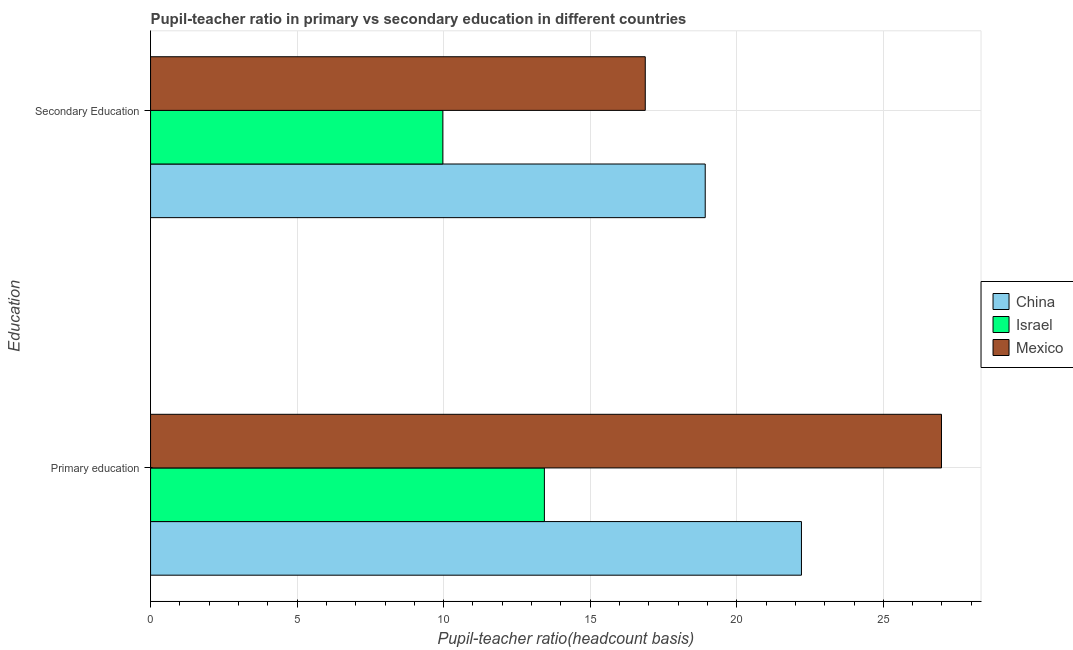How many different coloured bars are there?
Make the answer very short. 3. How many groups of bars are there?
Make the answer very short. 2. Are the number of bars per tick equal to the number of legend labels?
Offer a very short reply. Yes. Are the number of bars on each tick of the Y-axis equal?
Give a very brief answer. Yes. How many bars are there on the 1st tick from the top?
Your response must be concise. 3. What is the pupil teacher ratio on secondary education in China?
Your answer should be compact. 18.92. Across all countries, what is the maximum pupil-teacher ratio in primary education?
Offer a very short reply. 26.98. Across all countries, what is the minimum pupil teacher ratio on secondary education?
Ensure brevity in your answer.  9.97. In which country was the pupil-teacher ratio in primary education maximum?
Give a very brief answer. Mexico. What is the total pupil-teacher ratio in primary education in the graph?
Provide a succinct answer. 62.62. What is the difference between the pupil teacher ratio on secondary education in Mexico and that in Israel?
Provide a succinct answer. 6.91. What is the difference between the pupil-teacher ratio in primary education in China and the pupil teacher ratio on secondary education in Israel?
Make the answer very short. 12.23. What is the average pupil-teacher ratio in primary education per country?
Your response must be concise. 20.87. What is the difference between the pupil teacher ratio on secondary education and pupil-teacher ratio in primary education in China?
Your answer should be compact. -3.28. In how many countries, is the pupil-teacher ratio in primary education greater than 4 ?
Offer a very short reply. 3. What is the ratio of the pupil teacher ratio on secondary education in China to that in Israel?
Provide a succinct answer. 1.9. What does the 2nd bar from the bottom in Secondary Education represents?
Give a very brief answer. Israel. How many countries are there in the graph?
Offer a terse response. 3. Does the graph contain any zero values?
Offer a terse response. No. Does the graph contain grids?
Offer a terse response. Yes. Where does the legend appear in the graph?
Your answer should be compact. Center right. How are the legend labels stacked?
Keep it short and to the point. Vertical. What is the title of the graph?
Your response must be concise. Pupil-teacher ratio in primary vs secondary education in different countries. Does "High income: nonOECD" appear as one of the legend labels in the graph?
Give a very brief answer. No. What is the label or title of the X-axis?
Make the answer very short. Pupil-teacher ratio(headcount basis). What is the label or title of the Y-axis?
Your answer should be compact. Education. What is the Pupil-teacher ratio(headcount basis) in China in Primary education?
Provide a succinct answer. 22.21. What is the Pupil-teacher ratio(headcount basis) of Israel in Primary education?
Offer a very short reply. 13.44. What is the Pupil-teacher ratio(headcount basis) of Mexico in Primary education?
Keep it short and to the point. 26.98. What is the Pupil-teacher ratio(headcount basis) of China in Secondary Education?
Give a very brief answer. 18.92. What is the Pupil-teacher ratio(headcount basis) of Israel in Secondary Education?
Your response must be concise. 9.97. What is the Pupil-teacher ratio(headcount basis) of Mexico in Secondary Education?
Ensure brevity in your answer.  16.88. Across all Education, what is the maximum Pupil-teacher ratio(headcount basis) of China?
Your answer should be compact. 22.21. Across all Education, what is the maximum Pupil-teacher ratio(headcount basis) in Israel?
Your answer should be compact. 13.44. Across all Education, what is the maximum Pupil-teacher ratio(headcount basis) in Mexico?
Provide a short and direct response. 26.98. Across all Education, what is the minimum Pupil-teacher ratio(headcount basis) of China?
Your answer should be very brief. 18.92. Across all Education, what is the minimum Pupil-teacher ratio(headcount basis) in Israel?
Keep it short and to the point. 9.97. Across all Education, what is the minimum Pupil-teacher ratio(headcount basis) in Mexico?
Ensure brevity in your answer.  16.88. What is the total Pupil-teacher ratio(headcount basis) in China in the graph?
Your answer should be compact. 41.13. What is the total Pupil-teacher ratio(headcount basis) of Israel in the graph?
Make the answer very short. 23.41. What is the total Pupil-teacher ratio(headcount basis) in Mexico in the graph?
Give a very brief answer. 43.86. What is the difference between the Pupil-teacher ratio(headcount basis) of China in Primary education and that in Secondary Education?
Your answer should be very brief. 3.28. What is the difference between the Pupil-teacher ratio(headcount basis) of Israel in Primary education and that in Secondary Education?
Your answer should be compact. 3.46. What is the difference between the Pupil-teacher ratio(headcount basis) in Mexico in Primary education and that in Secondary Education?
Provide a short and direct response. 10.11. What is the difference between the Pupil-teacher ratio(headcount basis) of China in Primary education and the Pupil-teacher ratio(headcount basis) of Israel in Secondary Education?
Offer a terse response. 12.23. What is the difference between the Pupil-teacher ratio(headcount basis) of China in Primary education and the Pupil-teacher ratio(headcount basis) of Mexico in Secondary Education?
Provide a succinct answer. 5.33. What is the difference between the Pupil-teacher ratio(headcount basis) in Israel in Primary education and the Pupil-teacher ratio(headcount basis) in Mexico in Secondary Education?
Your answer should be very brief. -3.44. What is the average Pupil-teacher ratio(headcount basis) in China per Education?
Your response must be concise. 20.56. What is the average Pupil-teacher ratio(headcount basis) of Israel per Education?
Provide a short and direct response. 11.7. What is the average Pupil-teacher ratio(headcount basis) in Mexico per Education?
Your response must be concise. 21.93. What is the difference between the Pupil-teacher ratio(headcount basis) in China and Pupil-teacher ratio(headcount basis) in Israel in Primary education?
Your response must be concise. 8.77. What is the difference between the Pupil-teacher ratio(headcount basis) in China and Pupil-teacher ratio(headcount basis) in Mexico in Primary education?
Your answer should be compact. -4.78. What is the difference between the Pupil-teacher ratio(headcount basis) of Israel and Pupil-teacher ratio(headcount basis) of Mexico in Primary education?
Give a very brief answer. -13.55. What is the difference between the Pupil-teacher ratio(headcount basis) in China and Pupil-teacher ratio(headcount basis) in Israel in Secondary Education?
Offer a terse response. 8.95. What is the difference between the Pupil-teacher ratio(headcount basis) of China and Pupil-teacher ratio(headcount basis) of Mexico in Secondary Education?
Make the answer very short. 2.05. What is the difference between the Pupil-teacher ratio(headcount basis) in Israel and Pupil-teacher ratio(headcount basis) in Mexico in Secondary Education?
Your answer should be very brief. -6.91. What is the ratio of the Pupil-teacher ratio(headcount basis) in China in Primary education to that in Secondary Education?
Provide a succinct answer. 1.17. What is the ratio of the Pupil-teacher ratio(headcount basis) in Israel in Primary education to that in Secondary Education?
Ensure brevity in your answer.  1.35. What is the ratio of the Pupil-teacher ratio(headcount basis) of Mexico in Primary education to that in Secondary Education?
Keep it short and to the point. 1.6. What is the difference between the highest and the second highest Pupil-teacher ratio(headcount basis) in China?
Your answer should be very brief. 3.28. What is the difference between the highest and the second highest Pupil-teacher ratio(headcount basis) in Israel?
Give a very brief answer. 3.46. What is the difference between the highest and the second highest Pupil-teacher ratio(headcount basis) in Mexico?
Give a very brief answer. 10.11. What is the difference between the highest and the lowest Pupil-teacher ratio(headcount basis) in China?
Make the answer very short. 3.28. What is the difference between the highest and the lowest Pupil-teacher ratio(headcount basis) in Israel?
Ensure brevity in your answer.  3.46. What is the difference between the highest and the lowest Pupil-teacher ratio(headcount basis) in Mexico?
Provide a short and direct response. 10.11. 